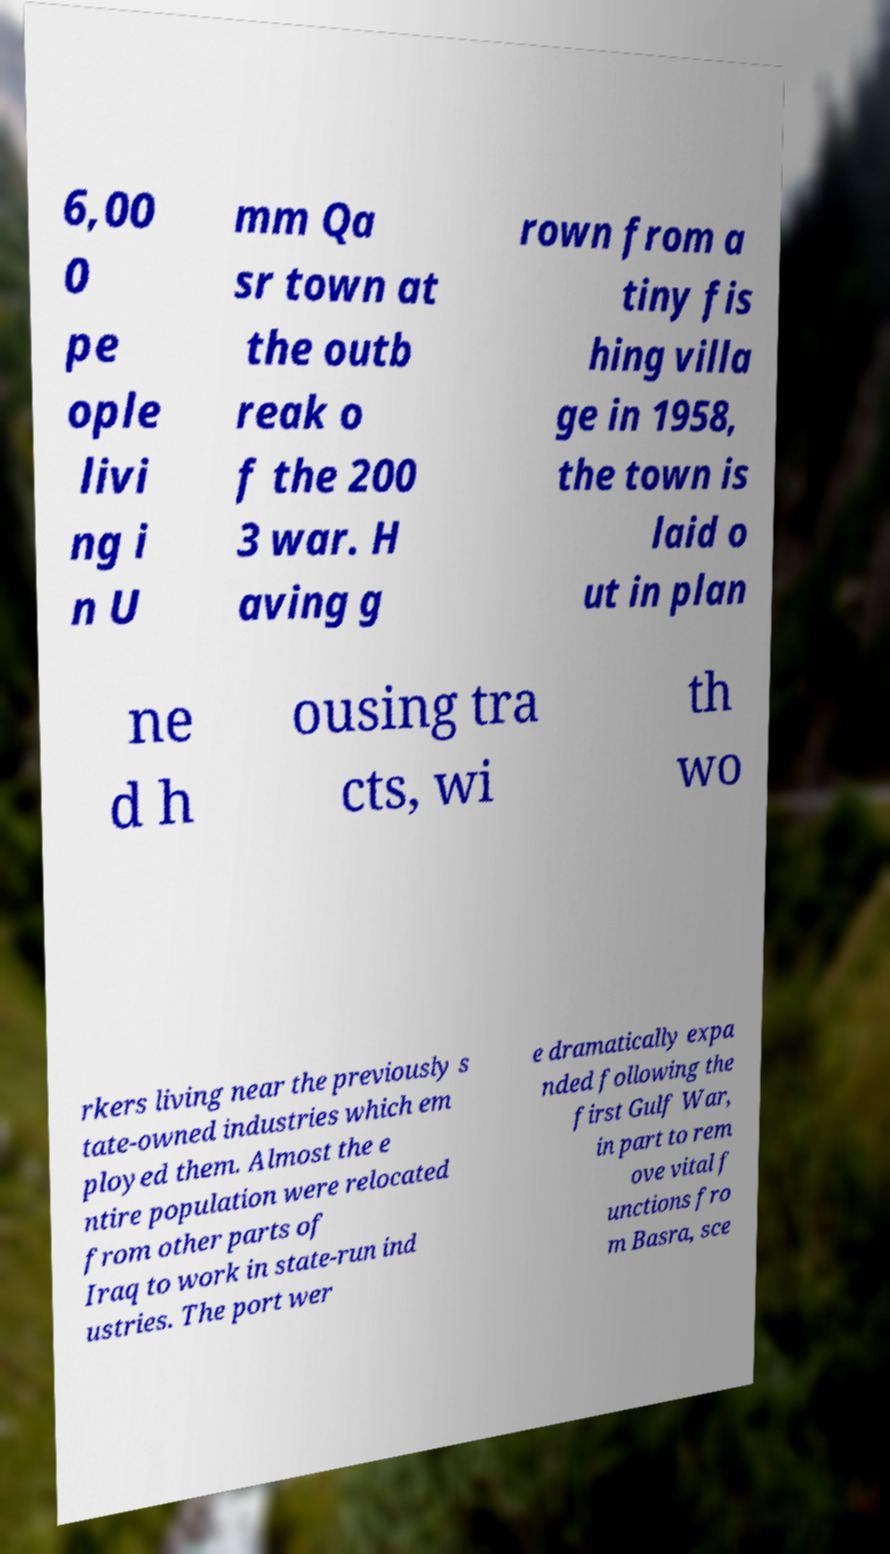For documentation purposes, I need the text within this image transcribed. Could you provide that? 6,00 0 pe ople livi ng i n U mm Qa sr town at the outb reak o f the 200 3 war. H aving g rown from a tiny fis hing villa ge in 1958, the town is laid o ut in plan ne d h ousing tra cts, wi th wo rkers living near the previously s tate-owned industries which em ployed them. Almost the e ntire population were relocated from other parts of Iraq to work in state-run ind ustries. The port wer e dramatically expa nded following the first Gulf War, in part to rem ove vital f unctions fro m Basra, sce 